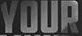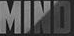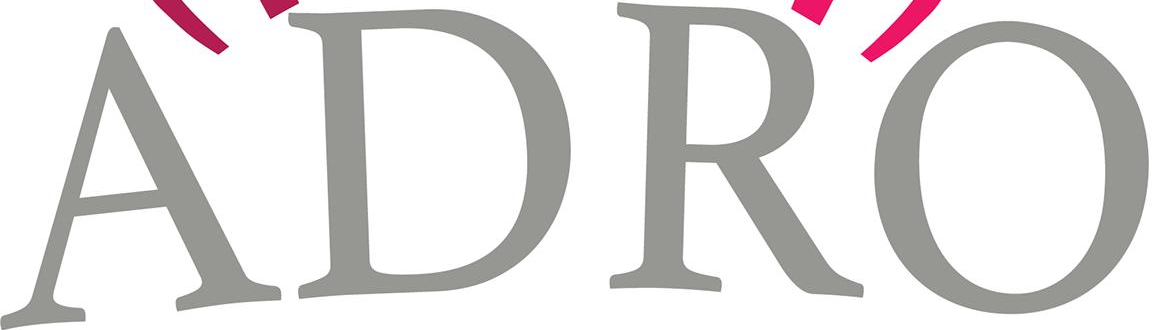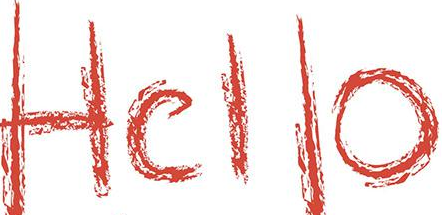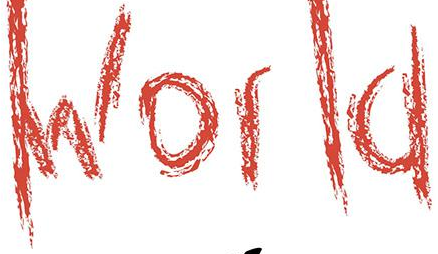What words can you see in these images in sequence, separated by a semicolon? YOUR; MIND; ADRO; Hello; World 